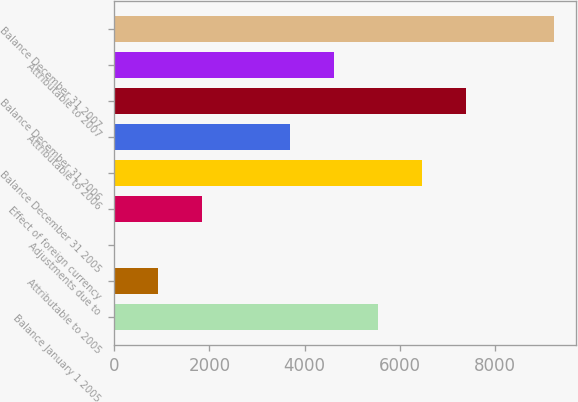<chart> <loc_0><loc_0><loc_500><loc_500><bar_chart><fcel>Balance January 1 2005<fcel>Attributable to 2005<fcel>Adjustments due to<fcel>Effect of foreign currency<fcel>Balance December 31 2005<fcel>Attributable to 2006<fcel>Balance December 31 2006<fcel>Attributable to 2007<fcel>Balance December 31 2007<nl><fcel>5545<fcel>925<fcel>1<fcel>1849<fcel>6469<fcel>3697<fcel>7393<fcel>4621<fcel>9241<nl></chart> 